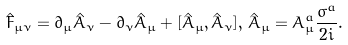Convert formula to latex. <formula><loc_0><loc_0><loc_500><loc_500>\hat { F } _ { \mu \nu } = \partial _ { \mu } \hat { A } _ { \nu } - \partial _ { \nu } \hat { A } _ { \mu } + [ \hat { A } _ { \mu } , \hat { A } _ { \nu } ] , \, \hat { A } _ { \mu } = A ^ { a } _ { \mu } \frac { \sigma ^ { a } } { 2 i } .</formula> 